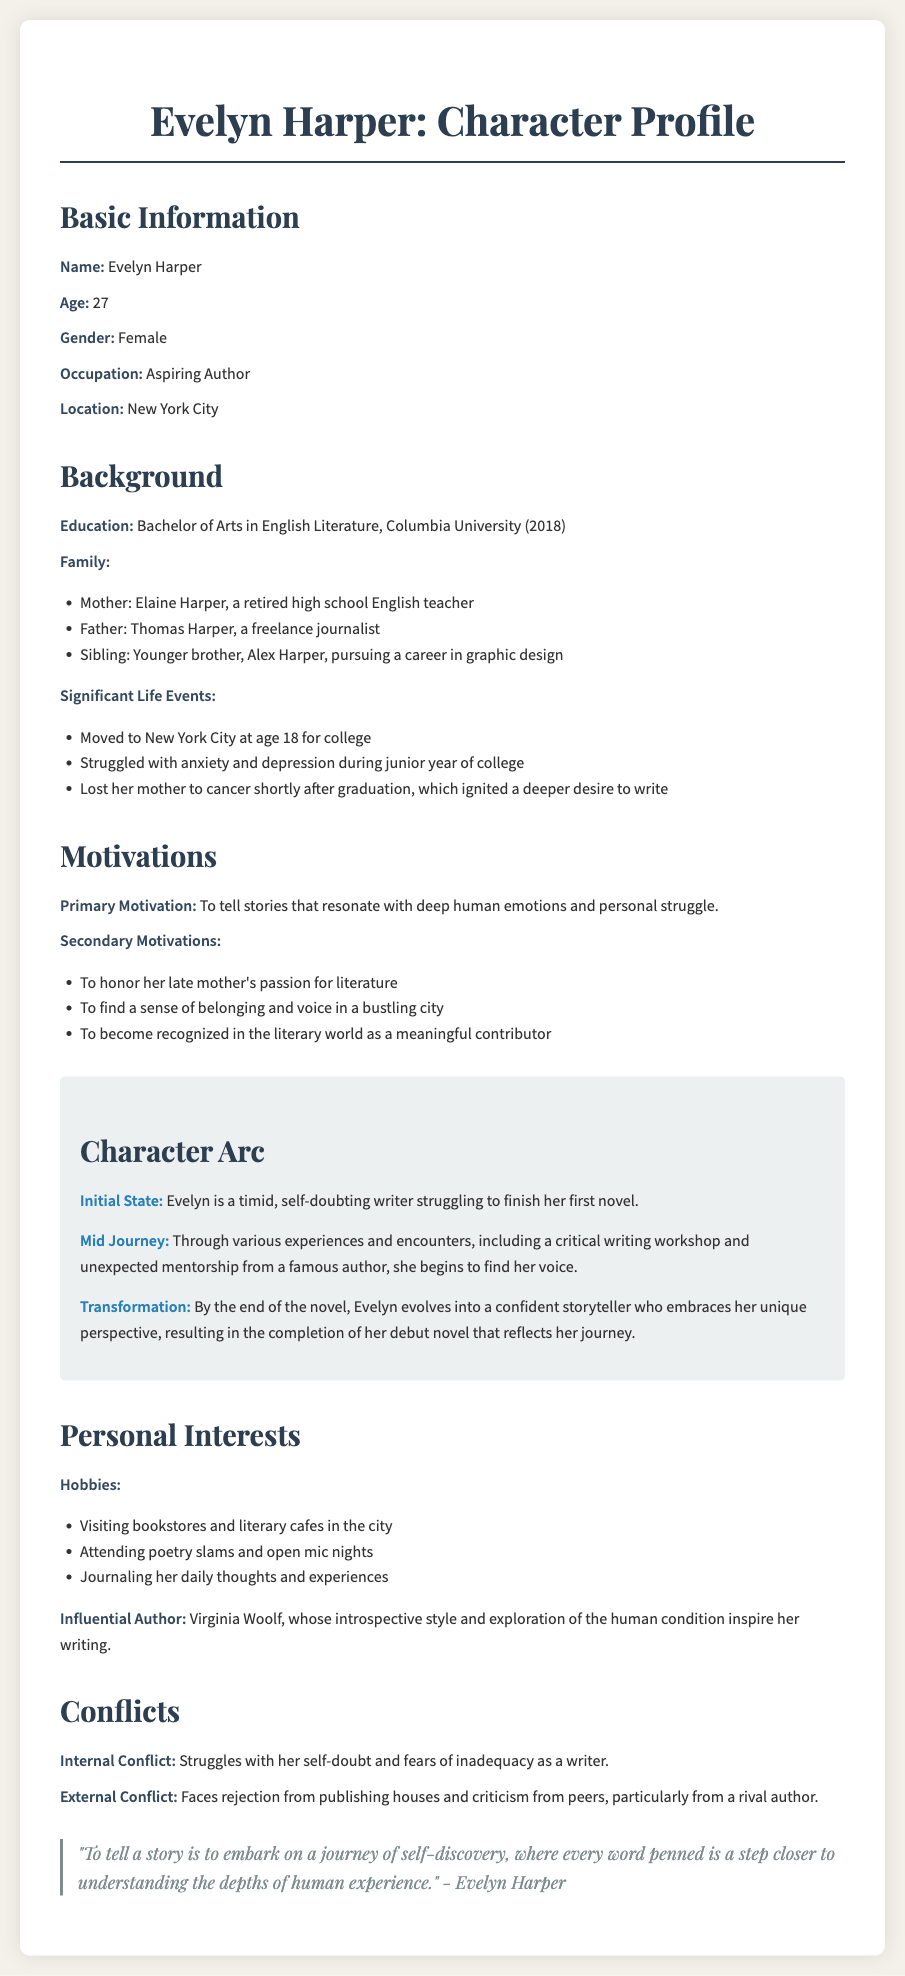What is the name of the protagonist? The name of the protagonist is explicitly stated in the document.
Answer: Evelyn Harper How old is Evelyn Harper? The document specifies Evelyn's age in the basic information section.
Answer: 27 What degree did Evelyn Harper earn? The education details are provided, mentioning her degree.
Answer: Bachelor of Arts in English Literature Who is Evelyn's influential author? The personal interests section lists an author that profoundly impacts Evelyn.
Answer: Virginia Woolf What significant life event occurred shortly after Evelyn's graduation? The document outlines major life events in Evelyn's background.
Answer: Lost her mother to cancer What is Evelyn's primary motivation? The motivations section describes her main driving force as a writer.
Answer: To tell stories that resonate with deep human emotions and personal struggle What is Evelyn's initial state at the beginning of her character arc? The character arc section outlines her starting point as a writer.
Answer: A timid, self-doubting writer struggling to finish her first novel What type of external conflict does Evelyn face? The conflicts section delineates the nature of her external challenges as a writer.
Answer: Faces rejection from publishing houses and criticism from peers What is the quote attributed to Evelyn Harper? A quote from Evelyn is presented in the document, reflecting her thoughts.
Answer: "To tell a story is to embark on a journey of self-discovery..." 